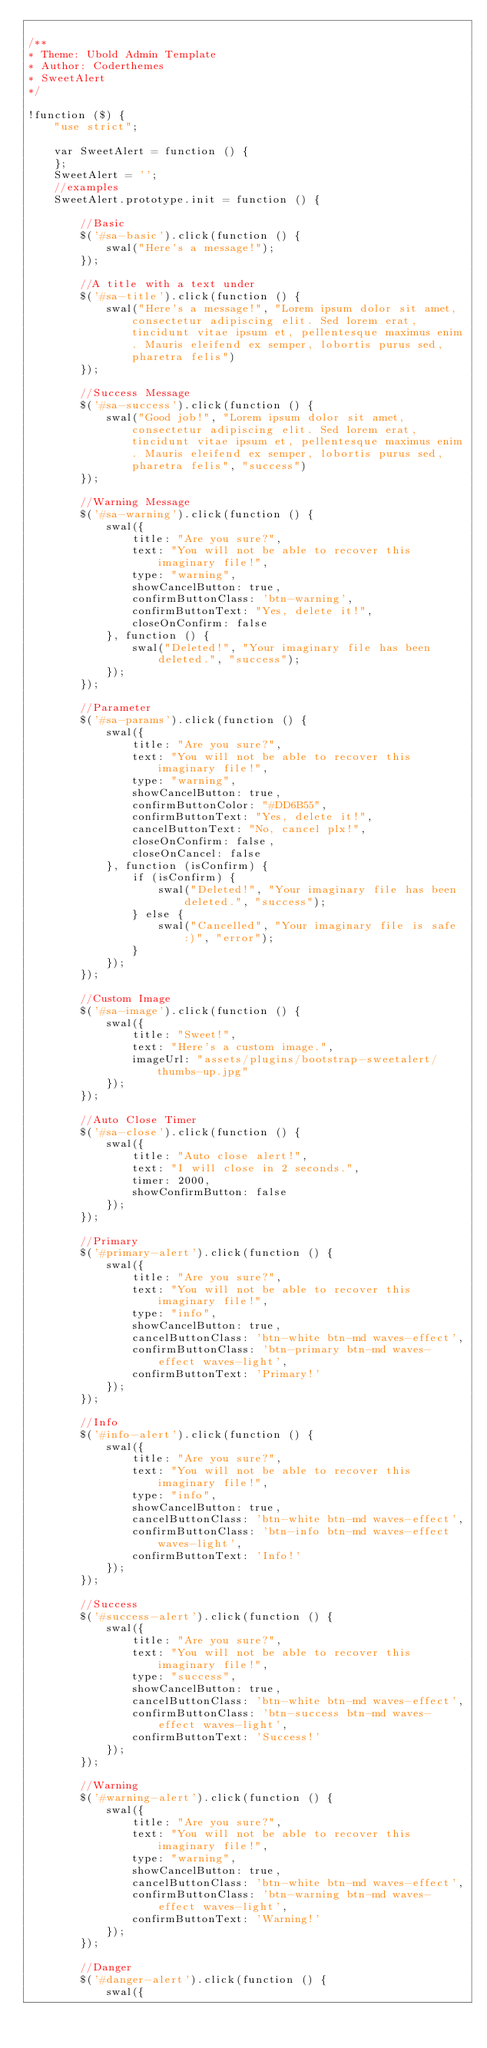Convert code to text. <code><loc_0><loc_0><loc_500><loc_500><_JavaScript_>
/**
* Theme: Ubold Admin Template
* Author: Coderthemes
* SweetAlert
*/

!function ($) {
    "use strict";

    var SweetAlert = function () {
    };
    SweetAlert = '';
    //examples
    SweetAlert.prototype.init = function () {

        //Basic
        $('#sa-basic').click(function () {
            swal("Here's a message!");
        });

        //A title with a text under
        $('#sa-title').click(function () {
            swal("Here's a message!", "Lorem ipsum dolor sit amet, consectetur adipiscing elit. Sed lorem erat, tincidunt vitae ipsum et, pellentesque maximus enim. Mauris eleifend ex semper, lobortis purus sed, pharetra felis")
        });

        //Success Message
        $('#sa-success').click(function () {
            swal("Good job!", "Lorem ipsum dolor sit amet, consectetur adipiscing elit. Sed lorem erat, tincidunt vitae ipsum et, pellentesque maximus enim. Mauris eleifend ex semper, lobortis purus sed, pharetra felis", "success")
        });

        //Warning Message
        $('#sa-warning').click(function () {
            swal({
                title: "Are you sure?",
                text: "You will not be able to recover this imaginary file!",
                type: "warning",
                showCancelButton: true,
                confirmButtonClass: 'btn-warning',
                confirmButtonText: "Yes, delete it!",
                closeOnConfirm: false
            }, function () {
                swal("Deleted!", "Your imaginary file has been deleted.", "success");
            });
        });

        //Parameter
        $('#sa-params').click(function () {
            swal({
                title: "Are you sure?",
                text: "You will not be able to recover this imaginary file!",
                type: "warning",
                showCancelButton: true,
                confirmButtonColor: "#DD6B55",
                confirmButtonText: "Yes, delete it!",
                cancelButtonText: "No, cancel plx!",
                closeOnConfirm: false,
                closeOnCancel: false
            }, function (isConfirm) {
                if (isConfirm) {
                    swal("Deleted!", "Your imaginary file has been deleted.", "success");
                } else {
                    swal("Cancelled", "Your imaginary file is safe :)", "error");
                }
            });
        });

        //Custom Image
        $('#sa-image').click(function () {
            swal({
                title: "Sweet!",
                text: "Here's a custom image.",
                imageUrl: "assets/plugins/bootstrap-sweetalert/thumbs-up.jpg"
            });
        });

        //Auto Close Timer
        $('#sa-close').click(function () {
            swal({
                title: "Auto close alert!",
                text: "I will close in 2 seconds.",
                timer: 2000,
                showConfirmButton: false
            });
        });

        //Primary
        $('#primary-alert').click(function () {
            swal({
                title: "Are you sure?",
                text: "You will not be able to recover this imaginary file!",
                type: "info",
                showCancelButton: true,
                cancelButtonClass: 'btn-white btn-md waves-effect',
                confirmButtonClass: 'btn-primary btn-md waves-effect waves-light',
                confirmButtonText: 'Primary!'
            });
        });

        //Info
        $('#info-alert').click(function () {
            swal({
                title: "Are you sure?",
                text: "You will not be able to recover this imaginary file!",
                type: "info",
                showCancelButton: true,
                cancelButtonClass: 'btn-white btn-md waves-effect',
                confirmButtonClass: 'btn-info btn-md waves-effect waves-light',
                confirmButtonText: 'Info!'
            });
        });

        //Success
        $('#success-alert').click(function () {
            swal({
                title: "Are you sure?",
                text: "You will not be able to recover this imaginary file!",
                type: "success",
                showCancelButton: true,
                cancelButtonClass: 'btn-white btn-md waves-effect',
                confirmButtonClass: 'btn-success btn-md waves-effect waves-light',
                confirmButtonText: 'Success!'
            });
        });

        //Warning
        $('#warning-alert').click(function () {
            swal({
                title: "Are you sure?",
                text: "You will not be able to recover this imaginary file!",
                type: "warning",
                showCancelButton: true,
                cancelButtonClass: 'btn-white btn-md waves-effect',
                confirmButtonClass: 'btn-warning btn-md waves-effect waves-light',
                confirmButtonText: 'Warning!'
            });
        });

        //Danger
        $('#danger-alert').click(function () {
            swal({</code> 